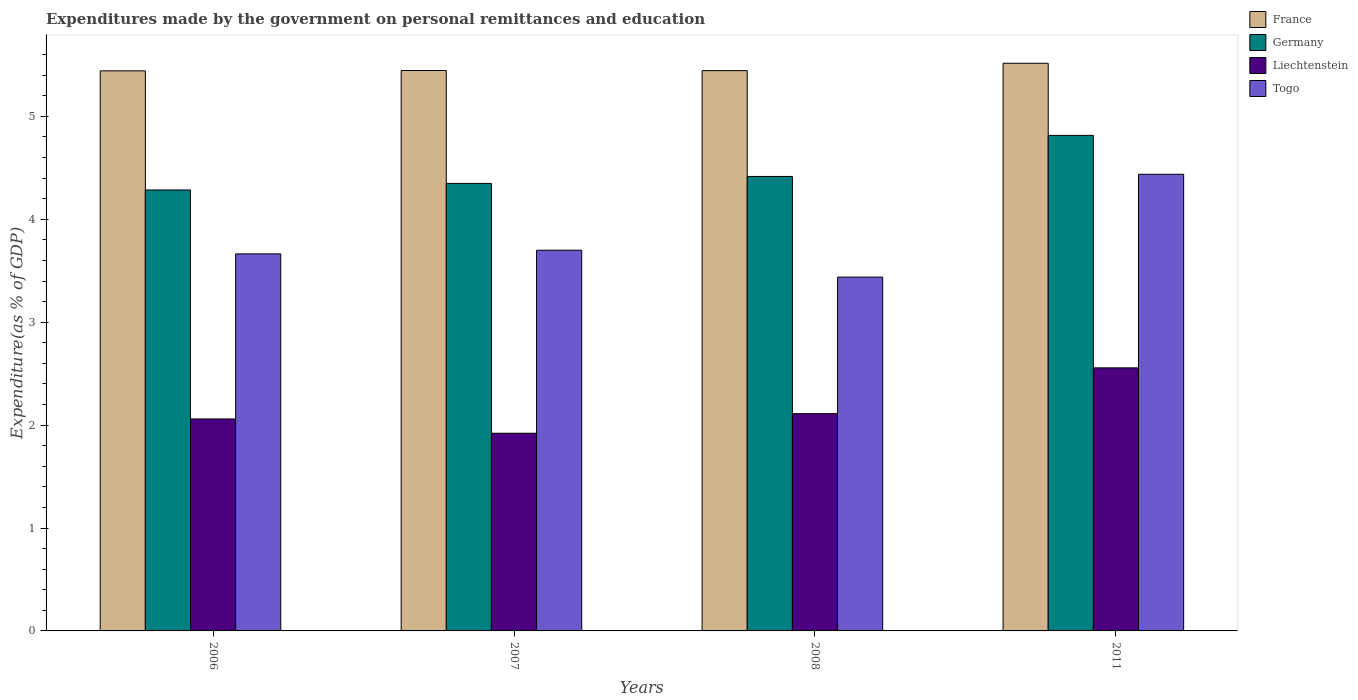How many different coloured bars are there?
Provide a short and direct response. 4. Are the number of bars per tick equal to the number of legend labels?
Keep it short and to the point. Yes. Are the number of bars on each tick of the X-axis equal?
Your answer should be very brief. Yes. What is the label of the 4th group of bars from the left?
Your answer should be very brief. 2011. In how many cases, is the number of bars for a given year not equal to the number of legend labels?
Provide a succinct answer. 0. What is the expenditures made by the government on personal remittances and education in Togo in 2007?
Your response must be concise. 3.7. Across all years, what is the maximum expenditures made by the government on personal remittances and education in Liechtenstein?
Keep it short and to the point. 2.56. Across all years, what is the minimum expenditures made by the government on personal remittances and education in Liechtenstein?
Ensure brevity in your answer.  1.92. In which year was the expenditures made by the government on personal remittances and education in Liechtenstein maximum?
Your response must be concise. 2011. What is the total expenditures made by the government on personal remittances and education in Togo in the graph?
Provide a succinct answer. 15.24. What is the difference between the expenditures made by the government on personal remittances and education in Togo in 2008 and that in 2011?
Offer a terse response. -1. What is the difference between the expenditures made by the government on personal remittances and education in France in 2011 and the expenditures made by the government on personal remittances and education in Togo in 2006?
Your answer should be very brief. 1.85. What is the average expenditures made by the government on personal remittances and education in Liechtenstein per year?
Your answer should be very brief. 2.16. In the year 2011, what is the difference between the expenditures made by the government on personal remittances and education in Togo and expenditures made by the government on personal remittances and education in Liechtenstein?
Your answer should be very brief. 1.88. In how many years, is the expenditures made by the government on personal remittances and education in Liechtenstein greater than 2.8 %?
Give a very brief answer. 0. What is the ratio of the expenditures made by the government on personal remittances and education in Liechtenstein in 2006 to that in 2008?
Your response must be concise. 0.98. Is the difference between the expenditures made by the government on personal remittances and education in Togo in 2007 and 2011 greater than the difference between the expenditures made by the government on personal remittances and education in Liechtenstein in 2007 and 2011?
Provide a succinct answer. No. What is the difference between the highest and the second highest expenditures made by the government on personal remittances and education in Liechtenstein?
Your response must be concise. 0.44. What is the difference between the highest and the lowest expenditures made by the government on personal remittances and education in Liechtenstein?
Keep it short and to the point. 0.64. Is the sum of the expenditures made by the government on personal remittances and education in France in 2006 and 2008 greater than the maximum expenditures made by the government on personal remittances and education in Togo across all years?
Offer a terse response. Yes. Is it the case that in every year, the sum of the expenditures made by the government on personal remittances and education in Togo and expenditures made by the government on personal remittances and education in Liechtenstein is greater than the sum of expenditures made by the government on personal remittances and education in France and expenditures made by the government on personal remittances and education in Germany?
Give a very brief answer. Yes. What does the 1st bar from the left in 2006 represents?
Your answer should be compact. France. What does the 3rd bar from the right in 2006 represents?
Your response must be concise. Germany. How many bars are there?
Your answer should be very brief. 16. Does the graph contain any zero values?
Make the answer very short. No. Does the graph contain grids?
Offer a very short reply. No. How are the legend labels stacked?
Provide a succinct answer. Vertical. What is the title of the graph?
Make the answer very short. Expenditures made by the government on personal remittances and education. What is the label or title of the X-axis?
Your answer should be compact. Years. What is the label or title of the Y-axis?
Your answer should be very brief. Expenditure(as % of GDP). What is the Expenditure(as % of GDP) of France in 2006?
Give a very brief answer. 5.44. What is the Expenditure(as % of GDP) in Germany in 2006?
Keep it short and to the point. 4.28. What is the Expenditure(as % of GDP) in Liechtenstein in 2006?
Your answer should be very brief. 2.06. What is the Expenditure(as % of GDP) in Togo in 2006?
Keep it short and to the point. 3.66. What is the Expenditure(as % of GDP) in France in 2007?
Give a very brief answer. 5.45. What is the Expenditure(as % of GDP) in Germany in 2007?
Your answer should be very brief. 4.35. What is the Expenditure(as % of GDP) of Liechtenstein in 2007?
Ensure brevity in your answer.  1.92. What is the Expenditure(as % of GDP) in Togo in 2007?
Provide a short and direct response. 3.7. What is the Expenditure(as % of GDP) in France in 2008?
Offer a very short reply. 5.44. What is the Expenditure(as % of GDP) of Germany in 2008?
Offer a very short reply. 4.42. What is the Expenditure(as % of GDP) of Liechtenstein in 2008?
Your answer should be compact. 2.11. What is the Expenditure(as % of GDP) of Togo in 2008?
Your answer should be compact. 3.44. What is the Expenditure(as % of GDP) of France in 2011?
Provide a succinct answer. 5.52. What is the Expenditure(as % of GDP) of Germany in 2011?
Your response must be concise. 4.81. What is the Expenditure(as % of GDP) in Liechtenstein in 2011?
Give a very brief answer. 2.56. What is the Expenditure(as % of GDP) of Togo in 2011?
Make the answer very short. 4.44. Across all years, what is the maximum Expenditure(as % of GDP) of France?
Make the answer very short. 5.52. Across all years, what is the maximum Expenditure(as % of GDP) of Germany?
Provide a succinct answer. 4.81. Across all years, what is the maximum Expenditure(as % of GDP) of Liechtenstein?
Your response must be concise. 2.56. Across all years, what is the maximum Expenditure(as % of GDP) in Togo?
Provide a short and direct response. 4.44. Across all years, what is the minimum Expenditure(as % of GDP) in France?
Provide a succinct answer. 5.44. Across all years, what is the minimum Expenditure(as % of GDP) of Germany?
Ensure brevity in your answer.  4.28. Across all years, what is the minimum Expenditure(as % of GDP) of Liechtenstein?
Ensure brevity in your answer.  1.92. Across all years, what is the minimum Expenditure(as % of GDP) in Togo?
Your answer should be compact. 3.44. What is the total Expenditure(as % of GDP) of France in the graph?
Your answer should be very brief. 21.85. What is the total Expenditure(as % of GDP) in Germany in the graph?
Your response must be concise. 17.86. What is the total Expenditure(as % of GDP) in Liechtenstein in the graph?
Keep it short and to the point. 8.65. What is the total Expenditure(as % of GDP) of Togo in the graph?
Your answer should be very brief. 15.24. What is the difference between the Expenditure(as % of GDP) of France in 2006 and that in 2007?
Offer a terse response. -0. What is the difference between the Expenditure(as % of GDP) of Germany in 2006 and that in 2007?
Provide a succinct answer. -0.06. What is the difference between the Expenditure(as % of GDP) in Liechtenstein in 2006 and that in 2007?
Offer a very short reply. 0.14. What is the difference between the Expenditure(as % of GDP) in Togo in 2006 and that in 2007?
Keep it short and to the point. -0.04. What is the difference between the Expenditure(as % of GDP) in France in 2006 and that in 2008?
Your answer should be very brief. -0. What is the difference between the Expenditure(as % of GDP) in Germany in 2006 and that in 2008?
Keep it short and to the point. -0.13. What is the difference between the Expenditure(as % of GDP) of Liechtenstein in 2006 and that in 2008?
Keep it short and to the point. -0.05. What is the difference between the Expenditure(as % of GDP) of Togo in 2006 and that in 2008?
Give a very brief answer. 0.23. What is the difference between the Expenditure(as % of GDP) in France in 2006 and that in 2011?
Offer a very short reply. -0.07. What is the difference between the Expenditure(as % of GDP) of Germany in 2006 and that in 2011?
Offer a terse response. -0.53. What is the difference between the Expenditure(as % of GDP) in Liechtenstein in 2006 and that in 2011?
Your response must be concise. -0.5. What is the difference between the Expenditure(as % of GDP) in Togo in 2006 and that in 2011?
Keep it short and to the point. -0.77. What is the difference between the Expenditure(as % of GDP) of France in 2007 and that in 2008?
Your answer should be compact. 0. What is the difference between the Expenditure(as % of GDP) in Germany in 2007 and that in 2008?
Your answer should be very brief. -0.07. What is the difference between the Expenditure(as % of GDP) of Liechtenstein in 2007 and that in 2008?
Keep it short and to the point. -0.19. What is the difference between the Expenditure(as % of GDP) in Togo in 2007 and that in 2008?
Offer a terse response. 0.26. What is the difference between the Expenditure(as % of GDP) in France in 2007 and that in 2011?
Your answer should be very brief. -0.07. What is the difference between the Expenditure(as % of GDP) of Germany in 2007 and that in 2011?
Offer a terse response. -0.47. What is the difference between the Expenditure(as % of GDP) of Liechtenstein in 2007 and that in 2011?
Offer a very short reply. -0.64. What is the difference between the Expenditure(as % of GDP) of Togo in 2007 and that in 2011?
Provide a succinct answer. -0.74. What is the difference between the Expenditure(as % of GDP) in France in 2008 and that in 2011?
Keep it short and to the point. -0.07. What is the difference between the Expenditure(as % of GDP) in Germany in 2008 and that in 2011?
Your answer should be compact. -0.4. What is the difference between the Expenditure(as % of GDP) of Liechtenstein in 2008 and that in 2011?
Your response must be concise. -0.44. What is the difference between the Expenditure(as % of GDP) in Togo in 2008 and that in 2011?
Provide a succinct answer. -1. What is the difference between the Expenditure(as % of GDP) in France in 2006 and the Expenditure(as % of GDP) in Germany in 2007?
Offer a very short reply. 1.09. What is the difference between the Expenditure(as % of GDP) of France in 2006 and the Expenditure(as % of GDP) of Liechtenstein in 2007?
Your response must be concise. 3.52. What is the difference between the Expenditure(as % of GDP) of France in 2006 and the Expenditure(as % of GDP) of Togo in 2007?
Keep it short and to the point. 1.74. What is the difference between the Expenditure(as % of GDP) in Germany in 2006 and the Expenditure(as % of GDP) in Liechtenstein in 2007?
Your answer should be compact. 2.36. What is the difference between the Expenditure(as % of GDP) in Germany in 2006 and the Expenditure(as % of GDP) in Togo in 2007?
Your answer should be compact. 0.59. What is the difference between the Expenditure(as % of GDP) of Liechtenstein in 2006 and the Expenditure(as % of GDP) of Togo in 2007?
Give a very brief answer. -1.64. What is the difference between the Expenditure(as % of GDP) in France in 2006 and the Expenditure(as % of GDP) in Germany in 2008?
Give a very brief answer. 1.03. What is the difference between the Expenditure(as % of GDP) in France in 2006 and the Expenditure(as % of GDP) in Liechtenstein in 2008?
Ensure brevity in your answer.  3.33. What is the difference between the Expenditure(as % of GDP) in France in 2006 and the Expenditure(as % of GDP) in Togo in 2008?
Provide a short and direct response. 2. What is the difference between the Expenditure(as % of GDP) in Germany in 2006 and the Expenditure(as % of GDP) in Liechtenstein in 2008?
Make the answer very short. 2.17. What is the difference between the Expenditure(as % of GDP) of Germany in 2006 and the Expenditure(as % of GDP) of Togo in 2008?
Your response must be concise. 0.85. What is the difference between the Expenditure(as % of GDP) in Liechtenstein in 2006 and the Expenditure(as % of GDP) in Togo in 2008?
Offer a terse response. -1.38. What is the difference between the Expenditure(as % of GDP) of France in 2006 and the Expenditure(as % of GDP) of Germany in 2011?
Ensure brevity in your answer.  0.63. What is the difference between the Expenditure(as % of GDP) in France in 2006 and the Expenditure(as % of GDP) in Liechtenstein in 2011?
Give a very brief answer. 2.89. What is the difference between the Expenditure(as % of GDP) in Germany in 2006 and the Expenditure(as % of GDP) in Liechtenstein in 2011?
Ensure brevity in your answer.  1.73. What is the difference between the Expenditure(as % of GDP) in Germany in 2006 and the Expenditure(as % of GDP) in Togo in 2011?
Your answer should be very brief. -0.15. What is the difference between the Expenditure(as % of GDP) in Liechtenstein in 2006 and the Expenditure(as % of GDP) in Togo in 2011?
Offer a very short reply. -2.38. What is the difference between the Expenditure(as % of GDP) of France in 2007 and the Expenditure(as % of GDP) of Germany in 2008?
Provide a short and direct response. 1.03. What is the difference between the Expenditure(as % of GDP) in France in 2007 and the Expenditure(as % of GDP) in Liechtenstein in 2008?
Offer a very short reply. 3.33. What is the difference between the Expenditure(as % of GDP) in France in 2007 and the Expenditure(as % of GDP) in Togo in 2008?
Offer a very short reply. 2.01. What is the difference between the Expenditure(as % of GDP) of Germany in 2007 and the Expenditure(as % of GDP) of Liechtenstein in 2008?
Keep it short and to the point. 2.24. What is the difference between the Expenditure(as % of GDP) in Germany in 2007 and the Expenditure(as % of GDP) in Togo in 2008?
Offer a very short reply. 0.91. What is the difference between the Expenditure(as % of GDP) in Liechtenstein in 2007 and the Expenditure(as % of GDP) in Togo in 2008?
Your answer should be very brief. -1.52. What is the difference between the Expenditure(as % of GDP) of France in 2007 and the Expenditure(as % of GDP) of Germany in 2011?
Give a very brief answer. 0.63. What is the difference between the Expenditure(as % of GDP) of France in 2007 and the Expenditure(as % of GDP) of Liechtenstein in 2011?
Provide a short and direct response. 2.89. What is the difference between the Expenditure(as % of GDP) of France in 2007 and the Expenditure(as % of GDP) of Togo in 2011?
Ensure brevity in your answer.  1.01. What is the difference between the Expenditure(as % of GDP) of Germany in 2007 and the Expenditure(as % of GDP) of Liechtenstein in 2011?
Provide a succinct answer. 1.79. What is the difference between the Expenditure(as % of GDP) of Germany in 2007 and the Expenditure(as % of GDP) of Togo in 2011?
Give a very brief answer. -0.09. What is the difference between the Expenditure(as % of GDP) of Liechtenstein in 2007 and the Expenditure(as % of GDP) of Togo in 2011?
Offer a terse response. -2.52. What is the difference between the Expenditure(as % of GDP) in France in 2008 and the Expenditure(as % of GDP) in Germany in 2011?
Offer a terse response. 0.63. What is the difference between the Expenditure(as % of GDP) of France in 2008 and the Expenditure(as % of GDP) of Liechtenstein in 2011?
Provide a short and direct response. 2.89. What is the difference between the Expenditure(as % of GDP) of Germany in 2008 and the Expenditure(as % of GDP) of Liechtenstein in 2011?
Make the answer very short. 1.86. What is the difference between the Expenditure(as % of GDP) in Germany in 2008 and the Expenditure(as % of GDP) in Togo in 2011?
Ensure brevity in your answer.  -0.02. What is the difference between the Expenditure(as % of GDP) of Liechtenstein in 2008 and the Expenditure(as % of GDP) of Togo in 2011?
Provide a short and direct response. -2.33. What is the average Expenditure(as % of GDP) in France per year?
Offer a terse response. 5.46. What is the average Expenditure(as % of GDP) in Germany per year?
Your response must be concise. 4.47. What is the average Expenditure(as % of GDP) of Liechtenstein per year?
Your answer should be compact. 2.16. What is the average Expenditure(as % of GDP) in Togo per year?
Offer a terse response. 3.81. In the year 2006, what is the difference between the Expenditure(as % of GDP) in France and Expenditure(as % of GDP) in Germany?
Ensure brevity in your answer.  1.16. In the year 2006, what is the difference between the Expenditure(as % of GDP) of France and Expenditure(as % of GDP) of Liechtenstein?
Give a very brief answer. 3.38. In the year 2006, what is the difference between the Expenditure(as % of GDP) of France and Expenditure(as % of GDP) of Togo?
Provide a short and direct response. 1.78. In the year 2006, what is the difference between the Expenditure(as % of GDP) of Germany and Expenditure(as % of GDP) of Liechtenstein?
Provide a short and direct response. 2.23. In the year 2006, what is the difference between the Expenditure(as % of GDP) in Germany and Expenditure(as % of GDP) in Togo?
Make the answer very short. 0.62. In the year 2006, what is the difference between the Expenditure(as % of GDP) of Liechtenstein and Expenditure(as % of GDP) of Togo?
Your answer should be compact. -1.6. In the year 2007, what is the difference between the Expenditure(as % of GDP) in France and Expenditure(as % of GDP) in Germany?
Make the answer very short. 1.1. In the year 2007, what is the difference between the Expenditure(as % of GDP) in France and Expenditure(as % of GDP) in Liechtenstein?
Offer a very short reply. 3.52. In the year 2007, what is the difference between the Expenditure(as % of GDP) of France and Expenditure(as % of GDP) of Togo?
Your answer should be very brief. 1.75. In the year 2007, what is the difference between the Expenditure(as % of GDP) in Germany and Expenditure(as % of GDP) in Liechtenstein?
Provide a short and direct response. 2.43. In the year 2007, what is the difference between the Expenditure(as % of GDP) in Germany and Expenditure(as % of GDP) in Togo?
Give a very brief answer. 0.65. In the year 2007, what is the difference between the Expenditure(as % of GDP) in Liechtenstein and Expenditure(as % of GDP) in Togo?
Offer a very short reply. -1.78. In the year 2008, what is the difference between the Expenditure(as % of GDP) in France and Expenditure(as % of GDP) in Germany?
Ensure brevity in your answer.  1.03. In the year 2008, what is the difference between the Expenditure(as % of GDP) in France and Expenditure(as % of GDP) in Liechtenstein?
Provide a succinct answer. 3.33. In the year 2008, what is the difference between the Expenditure(as % of GDP) in France and Expenditure(as % of GDP) in Togo?
Ensure brevity in your answer.  2.01. In the year 2008, what is the difference between the Expenditure(as % of GDP) of Germany and Expenditure(as % of GDP) of Liechtenstein?
Provide a succinct answer. 2.3. In the year 2008, what is the difference between the Expenditure(as % of GDP) in Germany and Expenditure(as % of GDP) in Togo?
Your answer should be compact. 0.98. In the year 2008, what is the difference between the Expenditure(as % of GDP) of Liechtenstein and Expenditure(as % of GDP) of Togo?
Provide a short and direct response. -1.33. In the year 2011, what is the difference between the Expenditure(as % of GDP) of France and Expenditure(as % of GDP) of Germany?
Ensure brevity in your answer.  0.7. In the year 2011, what is the difference between the Expenditure(as % of GDP) of France and Expenditure(as % of GDP) of Liechtenstein?
Your answer should be compact. 2.96. In the year 2011, what is the difference between the Expenditure(as % of GDP) in France and Expenditure(as % of GDP) in Togo?
Your answer should be very brief. 1.08. In the year 2011, what is the difference between the Expenditure(as % of GDP) of Germany and Expenditure(as % of GDP) of Liechtenstein?
Offer a very short reply. 2.26. In the year 2011, what is the difference between the Expenditure(as % of GDP) of Germany and Expenditure(as % of GDP) of Togo?
Offer a terse response. 0.38. In the year 2011, what is the difference between the Expenditure(as % of GDP) in Liechtenstein and Expenditure(as % of GDP) in Togo?
Keep it short and to the point. -1.88. What is the ratio of the Expenditure(as % of GDP) of Germany in 2006 to that in 2007?
Your answer should be compact. 0.99. What is the ratio of the Expenditure(as % of GDP) of Liechtenstein in 2006 to that in 2007?
Keep it short and to the point. 1.07. What is the ratio of the Expenditure(as % of GDP) of Togo in 2006 to that in 2007?
Keep it short and to the point. 0.99. What is the ratio of the Expenditure(as % of GDP) in Germany in 2006 to that in 2008?
Provide a succinct answer. 0.97. What is the ratio of the Expenditure(as % of GDP) of Liechtenstein in 2006 to that in 2008?
Ensure brevity in your answer.  0.98. What is the ratio of the Expenditure(as % of GDP) in Togo in 2006 to that in 2008?
Make the answer very short. 1.07. What is the ratio of the Expenditure(as % of GDP) in France in 2006 to that in 2011?
Offer a very short reply. 0.99. What is the ratio of the Expenditure(as % of GDP) of Germany in 2006 to that in 2011?
Make the answer very short. 0.89. What is the ratio of the Expenditure(as % of GDP) in Liechtenstein in 2006 to that in 2011?
Provide a succinct answer. 0.81. What is the ratio of the Expenditure(as % of GDP) in Togo in 2006 to that in 2011?
Ensure brevity in your answer.  0.83. What is the ratio of the Expenditure(as % of GDP) of France in 2007 to that in 2008?
Ensure brevity in your answer.  1. What is the ratio of the Expenditure(as % of GDP) of Germany in 2007 to that in 2008?
Offer a terse response. 0.98. What is the ratio of the Expenditure(as % of GDP) of Liechtenstein in 2007 to that in 2008?
Provide a short and direct response. 0.91. What is the ratio of the Expenditure(as % of GDP) in Togo in 2007 to that in 2008?
Your answer should be very brief. 1.08. What is the ratio of the Expenditure(as % of GDP) in France in 2007 to that in 2011?
Ensure brevity in your answer.  0.99. What is the ratio of the Expenditure(as % of GDP) in Germany in 2007 to that in 2011?
Provide a short and direct response. 0.9. What is the ratio of the Expenditure(as % of GDP) in Liechtenstein in 2007 to that in 2011?
Offer a very short reply. 0.75. What is the ratio of the Expenditure(as % of GDP) in Togo in 2007 to that in 2011?
Your answer should be compact. 0.83. What is the ratio of the Expenditure(as % of GDP) in Germany in 2008 to that in 2011?
Make the answer very short. 0.92. What is the ratio of the Expenditure(as % of GDP) of Liechtenstein in 2008 to that in 2011?
Provide a short and direct response. 0.83. What is the ratio of the Expenditure(as % of GDP) in Togo in 2008 to that in 2011?
Your response must be concise. 0.77. What is the difference between the highest and the second highest Expenditure(as % of GDP) in France?
Your response must be concise. 0.07. What is the difference between the highest and the second highest Expenditure(as % of GDP) in Germany?
Give a very brief answer. 0.4. What is the difference between the highest and the second highest Expenditure(as % of GDP) of Liechtenstein?
Offer a terse response. 0.44. What is the difference between the highest and the second highest Expenditure(as % of GDP) of Togo?
Offer a terse response. 0.74. What is the difference between the highest and the lowest Expenditure(as % of GDP) in France?
Ensure brevity in your answer.  0.07. What is the difference between the highest and the lowest Expenditure(as % of GDP) in Germany?
Your answer should be compact. 0.53. What is the difference between the highest and the lowest Expenditure(as % of GDP) in Liechtenstein?
Your response must be concise. 0.64. What is the difference between the highest and the lowest Expenditure(as % of GDP) of Togo?
Your answer should be compact. 1. 